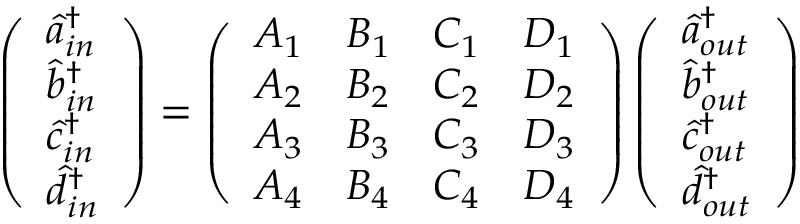Convert formula to latex. <formula><loc_0><loc_0><loc_500><loc_500>\left ( \begin{array} { l } { \hat { a } _ { i n } ^ { \dagger } } \\ { \hat { b } _ { i n } ^ { \dagger } } \\ { \hat { c } _ { i n } ^ { \dagger } } \\ { \hat { d } _ { i n } ^ { \dagger } } \end{array} \right ) = \left ( \begin{array} { l l l l } { A _ { 1 } } & { B _ { 1 } } & { C _ { 1 } } & { D _ { 1 } } \\ { A _ { 2 } } & { B _ { 2 } } & { C _ { 2 } } & { D _ { 2 } } \\ { A _ { 3 } } & { B _ { 3 } } & { C _ { 3 } } & { D _ { 3 } } \\ { A _ { 4 } } & { B _ { 4 } } & { C _ { 4 } } & { D _ { 4 } } \end{array} \right ) \left ( \begin{array} { l } { \hat { a } _ { o u t } ^ { \dagger } } \\ { \hat { b } _ { o u t } ^ { \dagger } } \\ { \hat { c } _ { o u t } ^ { \dagger } } \\ { \hat { d } _ { o u t } ^ { \dagger } } \end{array} \right )</formula> 